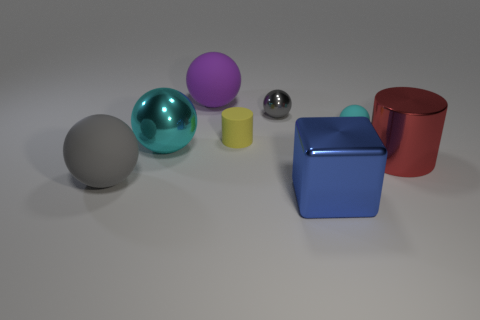Subtract all purple balls. How many balls are left? 4 Subtract all purple balls. How many balls are left? 4 Subtract all brown balls. Subtract all green cylinders. How many balls are left? 5 Add 2 small red shiny blocks. How many objects exist? 10 Subtract all blocks. How many objects are left? 7 Subtract 1 red cylinders. How many objects are left? 7 Subtract all metallic spheres. Subtract all blocks. How many objects are left? 5 Add 1 cubes. How many cubes are left? 2 Add 1 small blue rubber objects. How many small blue rubber objects exist? 1 